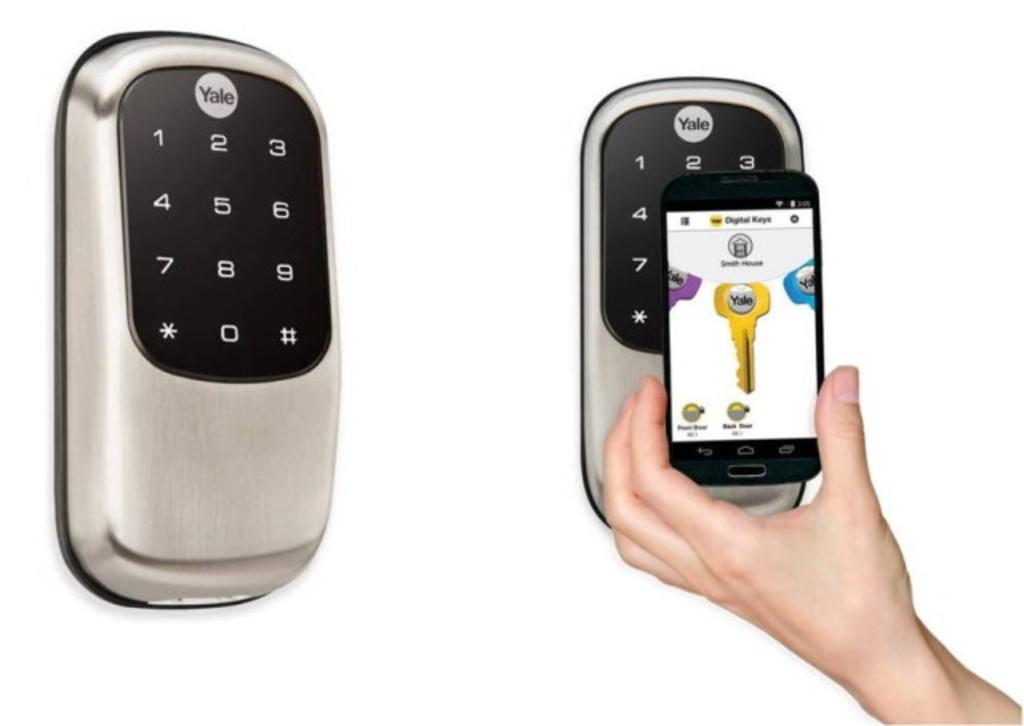What type of lock is shown in the image? There are smart locks in the image. Can you describe the interaction between the human hand and the smart lock? A human hand is holding a mobile near to the smart lock. What type of books can be seen in the image? There are no books present in the image. What is the condition of the pest in the image? There is no pest present in the image. 